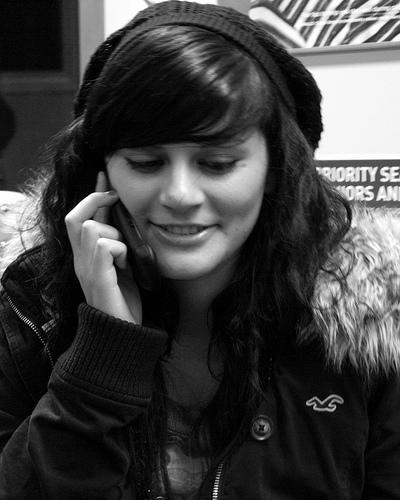Question: when is the picture taken?
Choices:
A. Day time.
B. Night time.
C. Noone.
D. Midnight.
Answer with the letter. Answer: B Question: what is the color of the hair?
Choices:
A. Brown.
B. Blonde.
C. Gray.
D. Black.
Answer with the letter. Answer: D Question: what is the color of the wall?
Choices:
A. Beige.
B. Yellow.
C. Blue.
D. White.
Answer with the letter. Answer: D Question: how many mobile?
Choices:
A. Two.
B. Three.
C. One.
D. Five.
Answer with the letter. Answer: C Question: what is the symbol in the shirt?
Choices:
A. Crocodile.
B. Fish.
C. Cat.
D. Bird.
Answer with the letter. Answer: D 